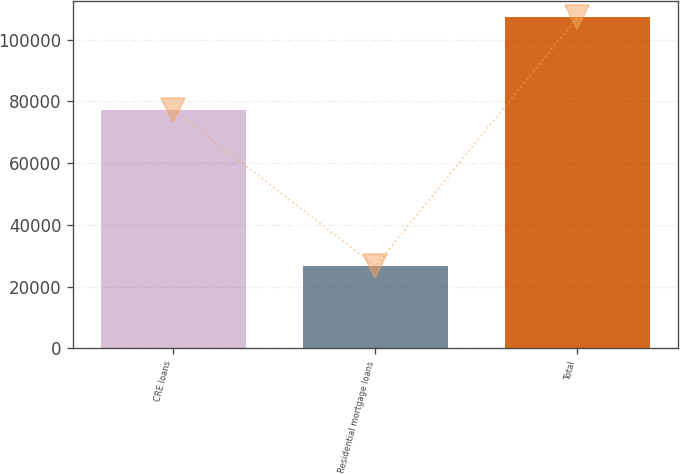<chart> <loc_0><loc_0><loc_500><loc_500><bar_chart><fcel>CRE loans<fcel>Residential mortgage loans<fcel>Total<nl><fcel>77316<fcel>26686<fcel>107224<nl></chart> 